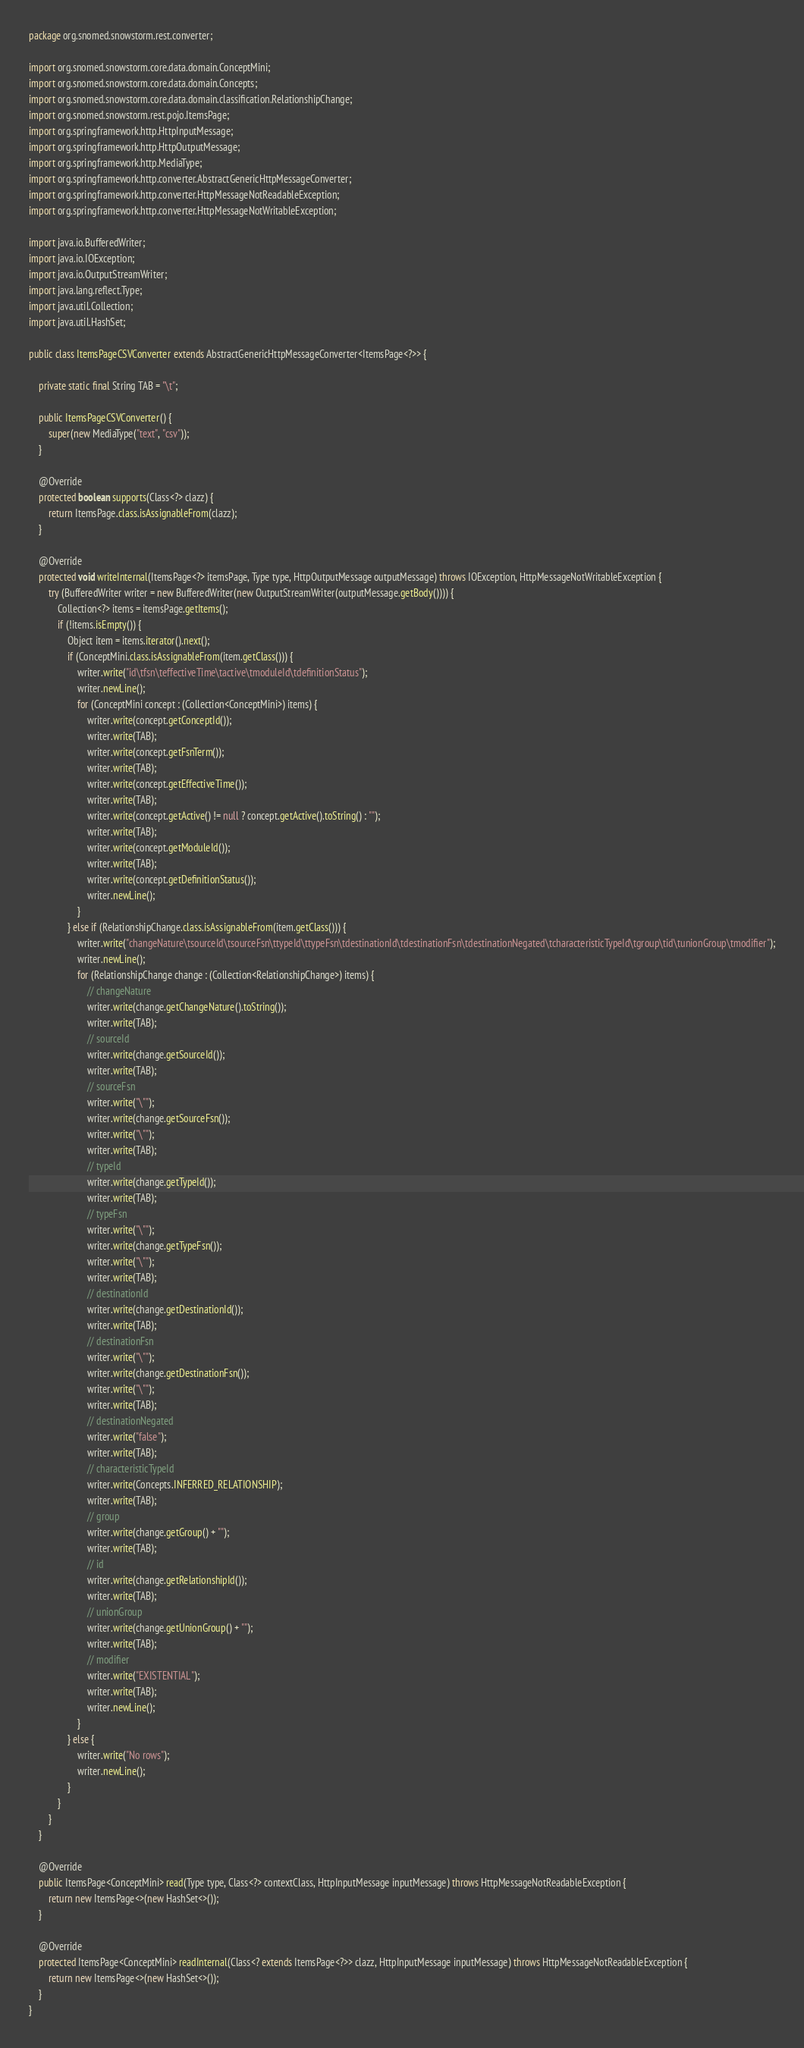Convert code to text. <code><loc_0><loc_0><loc_500><loc_500><_Java_>package org.snomed.snowstorm.rest.converter;

import org.snomed.snowstorm.core.data.domain.ConceptMini;
import org.snomed.snowstorm.core.data.domain.Concepts;
import org.snomed.snowstorm.core.data.domain.classification.RelationshipChange;
import org.snomed.snowstorm.rest.pojo.ItemsPage;
import org.springframework.http.HttpInputMessage;
import org.springframework.http.HttpOutputMessage;
import org.springframework.http.MediaType;
import org.springframework.http.converter.AbstractGenericHttpMessageConverter;
import org.springframework.http.converter.HttpMessageNotReadableException;
import org.springframework.http.converter.HttpMessageNotWritableException;

import java.io.BufferedWriter;
import java.io.IOException;
import java.io.OutputStreamWriter;
import java.lang.reflect.Type;
import java.util.Collection;
import java.util.HashSet;

public class ItemsPageCSVConverter extends AbstractGenericHttpMessageConverter<ItemsPage<?>> {

	private static final String TAB = "\t";

	public ItemsPageCSVConverter() {
		super(new MediaType("text", "csv"));
	}

	@Override
	protected boolean supports(Class<?> clazz) {
		return ItemsPage.class.isAssignableFrom(clazz);
	}

	@Override
	protected void writeInternal(ItemsPage<?> itemsPage, Type type, HttpOutputMessage outputMessage) throws IOException, HttpMessageNotWritableException {
		try (BufferedWriter writer = new BufferedWriter(new OutputStreamWriter(outputMessage.getBody()))) {
			Collection<?> items = itemsPage.getItems();
			if (!items.isEmpty()) {
				Object item = items.iterator().next();
				if (ConceptMini.class.isAssignableFrom(item.getClass())) {
					writer.write("id\tfsn\teffectiveTime\tactive\tmoduleId\tdefinitionStatus");
					writer.newLine();
					for (ConceptMini concept : (Collection<ConceptMini>) items) {
						writer.write(concept.getConceptId());
						writer.write(TAB);
						writer.write(concept.getFsnTerm());
						writer.write(TAB);
						writer.write(concept.getEffectiveTime());
						writer.write(TAB);
						writer.write(concept.getActive() != null ? concept.getActive().toString() : "");
						writer.write(TAB);
						writer.write(concept.getModuleId());
						writer.write(TAB);
						writer.write(concept.getDefinitionStatus());
						writer.newLine();
					}
				} else if (RelationshipChange.class.isAssignableFrom(item.getClass())) {
					writer.write("changeNature\tsourceId\tsourceFsn\ttypeId\ttypeFsn\tdestinationId\tdestinationFsn\tdestinationNegated\tcharacteristicTypeId\tgroup\tid\tunionGroup\tmodifier");
					writer.newLine();
					for (RelationshipChange change : (Collection<RelationshipChange>) items) {
						// changeNature
						writer.write(change.getChangeNature().toString());
						writer.write(TAB);
						// sourceId
						writer.write(change.getSourceId());
						writer.write(TAB);
						// sourceFsn
						writer.write("\"");
						writer.write(change.getSourceFsn());
						writer.write("\"");
						writer.write(TAB);
						// typeId
						writer.write(change.getTypeId());
						writer.write(TAB);
						// typeFsn
						writer.write("\"");
						writer.write(change.getTypeFsn());
						writer.write("\"");
						writer.write(TAB);
						// destinationId
						writer.write(change.getDestinationId());
						writer.write(TAB);
						// destinationFsn
						writer.write("\"");
						writer.write(change.getDestinationFsn());
						writer.write("\"");
						writer.write(TAB);
						// destinationNegated
						writer.write("false");
						writer.write(TAB);
						// characteristicTypeId
						writer.write(Concepts.INFERRED_RELATIONSHIP);
						writer.write(TAB);
						// group
						writer.write(change.getGroup() + "");
						writer.write(TAB);
						// id
						writer.write(change.getRelationshipId());
						writer.write(TAB);
						// unionGroup
						writer.write(change.getUnionGroup() + "");
						writer.write(TAB);
						// modifier
						writer.write("EXISTENTIAL");
						writer.write(TAB);
						writer.newLine();
					}
				} else {
					writer.write("No rows");
					writer.newLine();
				}
			}
		}
	}

	@Override
	public ItemsPage<ConceptMini> read(Type type, Class<?> contextClass, HttpInputMessage inputMessage) throws HttpMessageNotReadableException {
		return new ItemsPage<>(new HashSet<>());
	}

	@Override
	protected ItemsPage<ConceptMini> readInternal(Class<? extends ItemsPage<?>> clazz, HttpInputMessage inputMessage) throws HttpMessageNotReadableException {
		return new ItemsPage<>(new HashSet<>());
	}
}
</code> 